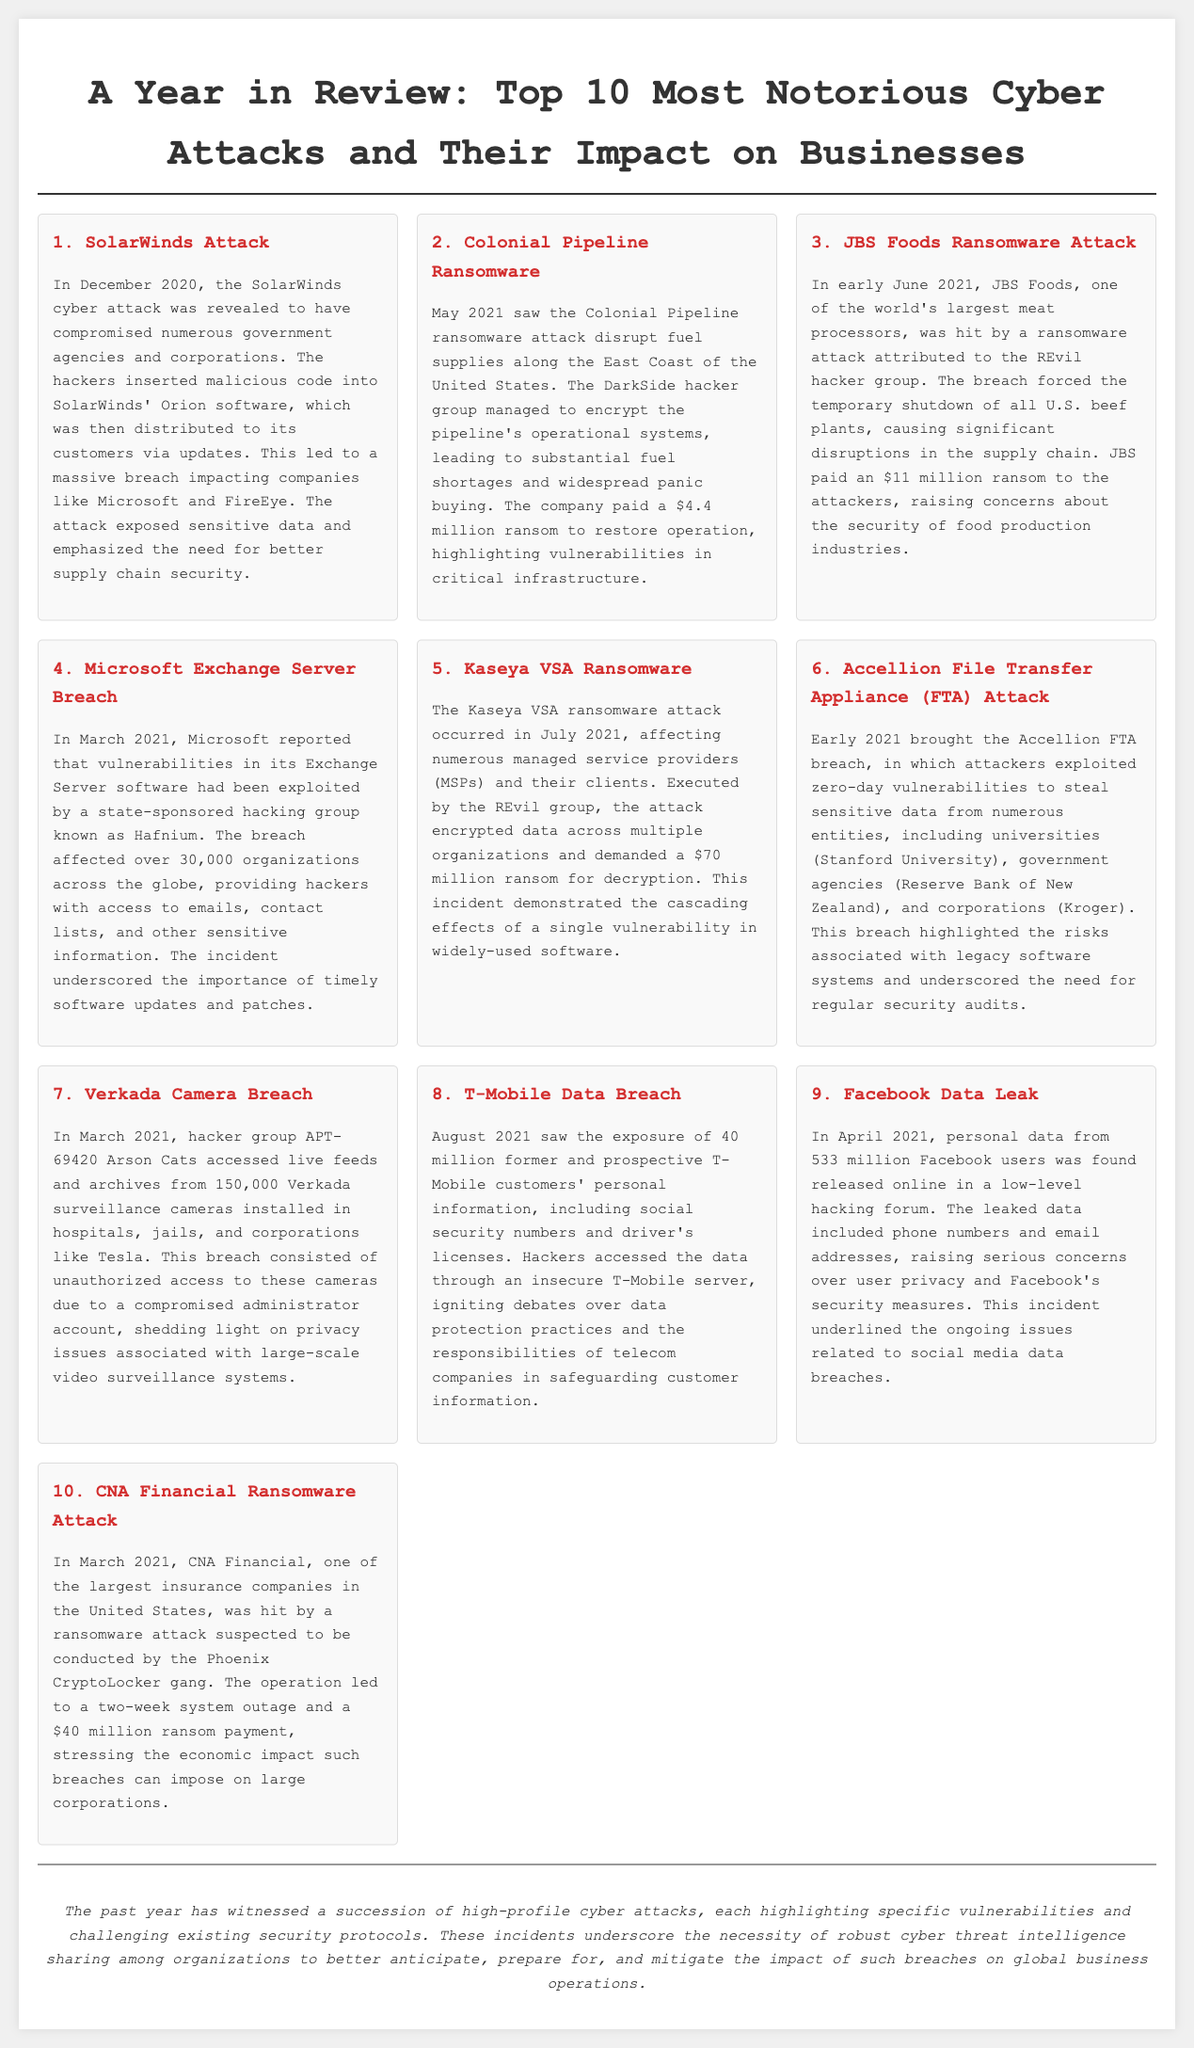What was the date of the SolarWinds attack? The document states that the SolarWinds cyber attack was revealed in December 2020.
Answer: December 2020 How much ransom did Colonial Pipeline pay? The article specifies that Colonial Pipeline paid a $4.4 million ransom to restore operations.
Answer: $4.4 million Which hacker group was responsible for the JBS Foods attack? According to the document, the ransomware attack on JBS Foods was attributed to the REvil hacker group.
Answer: REvil How many organizations were affected by the Microsoft Exchange Server breach? The document mentions that over 30,000 organizations were impacted by the vulnerabilities exploited in Microsoft Exchange Server.
Answer: Over 30,000 What type of attack occurred at T-Mobile in August 2021? The article describes the incident as a data breach that exposed personal information of customers.
Answer: Data breach What does the conclusion emphasize about cyber threat intelligence? The conclusion highlights the necessity of robust cyber threat intelligence sharing among organizations.
Answer: Robust cyber threat intelligence sharing What was the common consequence of the attacks mentioned? The document discusses disruptions and ransom payments as common consequences of the attacks described.
Answer: Disruptions and ransom payments Which company was attacked by the Phoenix CryptoLocker gang? The article identifies CNA Financial as the company attacked by the Phoenix CryptoLocker gang.
Answer: CNA Financial What type of document is this layout representing? The overall structure and content indicate that this is a newspaper-style layout discussing cyber attacks.
Answer: Newspaper layout 